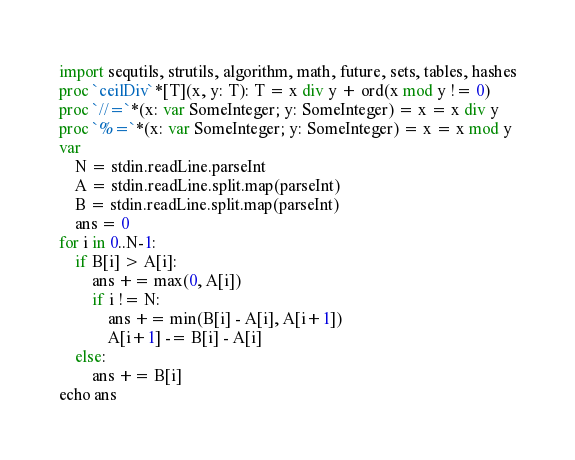<code> <loc_0><loc_0><loc_500><loc_500><_Nim_>import sequtils, strutils, algorithm, math, future, sets, tables, hashes
proc `ceilDiv`*[T](x, y: T): T = x div y + ord(x mod y != 0)
proc `//=`*(x: var SomeInteger; y: SomeInteger) = x = x div y
proc `%=`*(x: var SomeInteger; y: SomeInteger) = x = x mod y
var
    N = stdin.readLine.parseInt
    A = stdin.readLine.split.map(parseInt)
    B = stdin.readLine.split.map(parseInt)
    ans = 0
for i in 0..N-1:
    if B[i] > A[i]:
        ans += max(0, A[i])
        if i != N:
            ans += min(B[i] - A[i], A[i+1])
            A[i+1] -= B[i] - A[i]
    else:
        ans += B[i]
echo ans</code> 